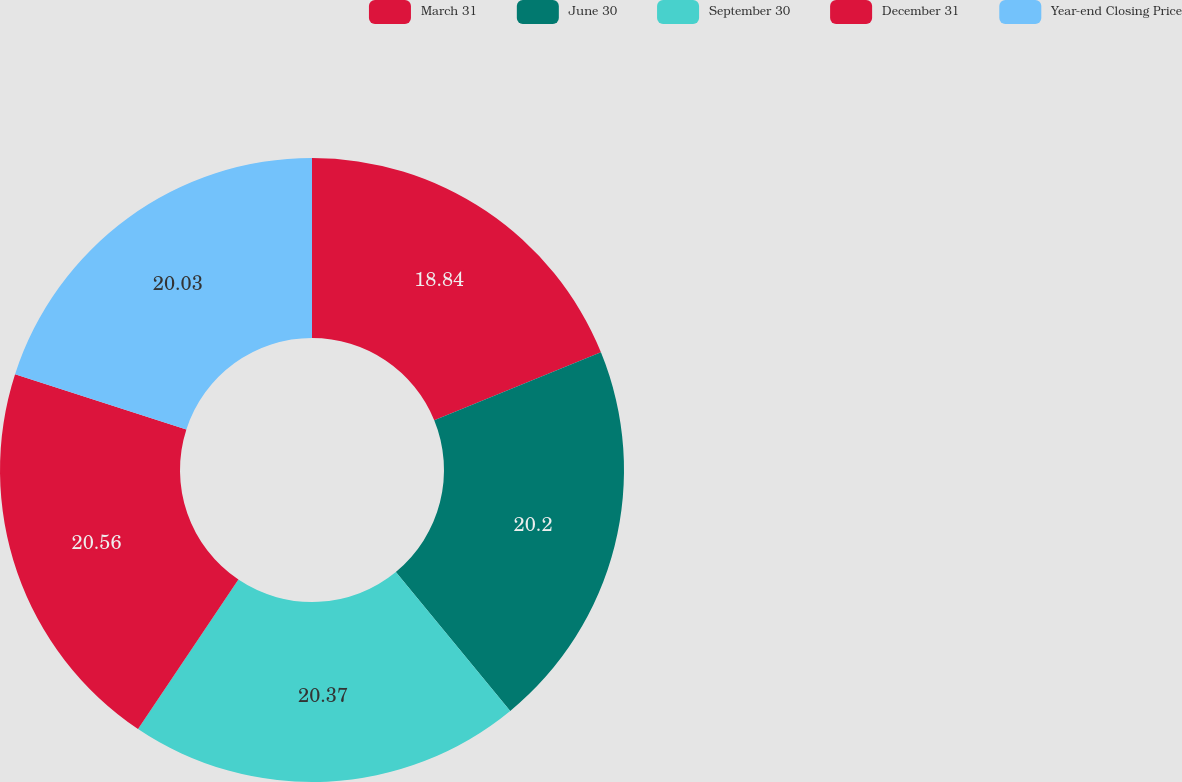Convert chart to OTSL. <chart><loc_0><loc_0><loc_500><loc_500><pie_chart><fcel>March 31<fcel>June 30<fcel>September 30<fcel>December 31<fcel>Year-end Closing Price<nl><fcel>18.84%<fcel>20.2%<fcel>20.37%<fcel>20.55%<fcel>20.03%<nl></chart> 